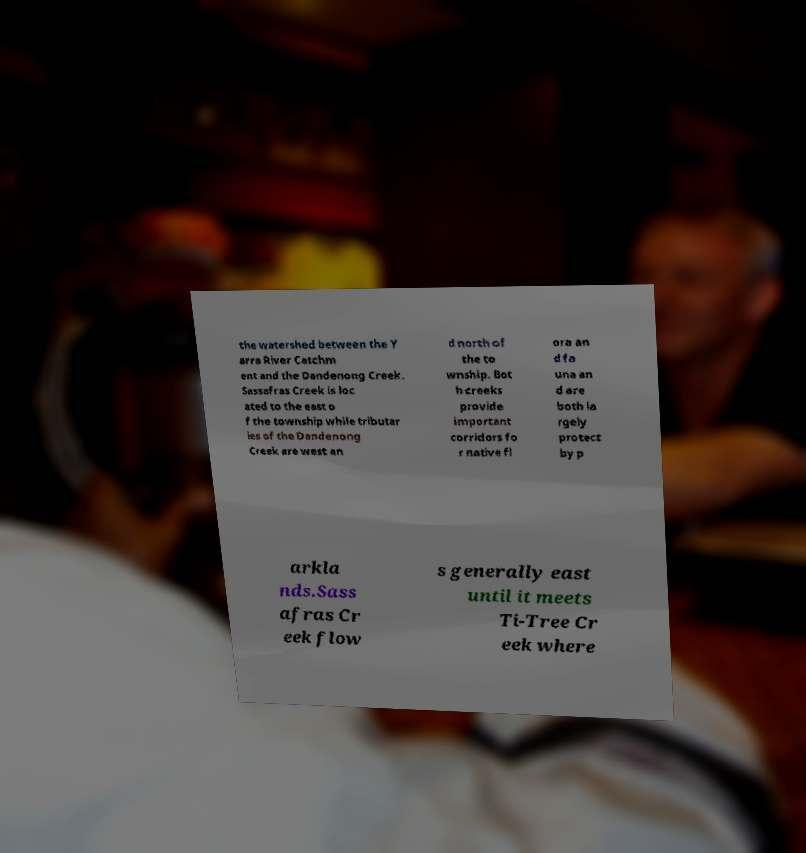Could you extract and type out the text from this image? the watershed between the Y arra River Catchm ent and the Dandenong Creek. Sassafras Creek is loc ated to the east o f the township while tributar ies of the Dandenong Creek are west an d north of the to wnship. Bot h creeks provide important corridors fo r native fl ora an d fa una an d are both la rgely protect by p arkla nds.Sass afras Cr eek flow s generally east until it meets Ti-Tree Cr eek where 